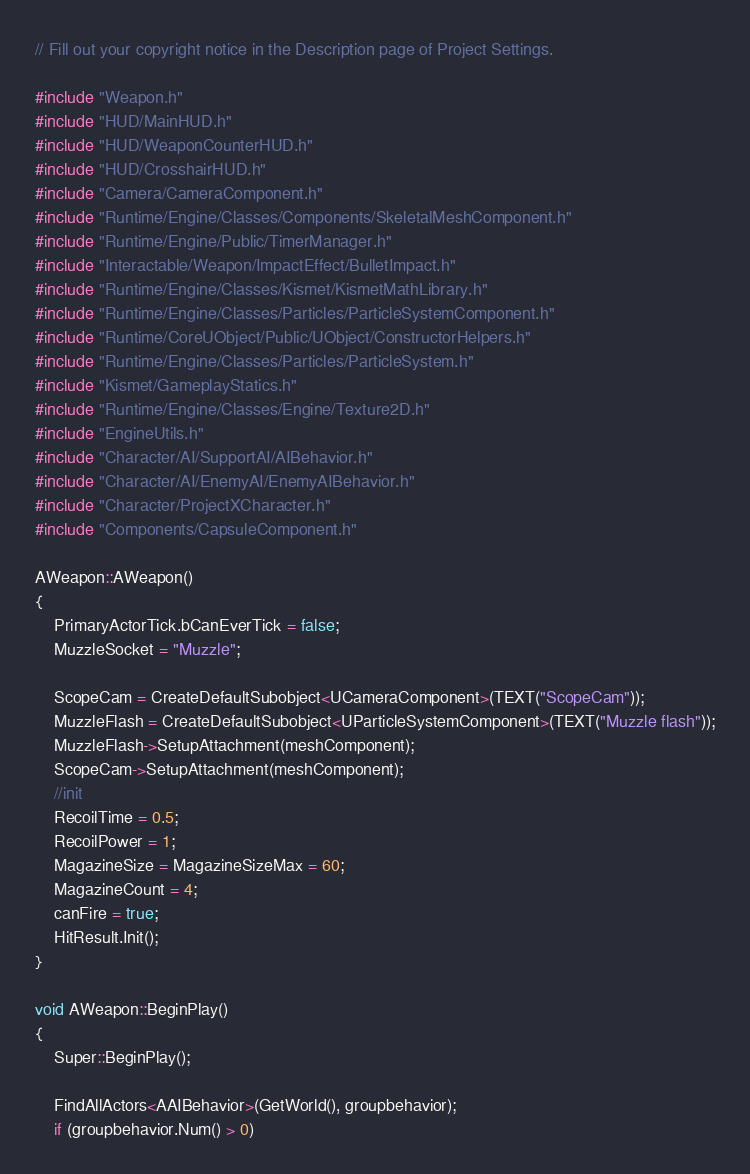Convert code to text. <code><loc_0><loc_0><loc_500><loc_500><_C++_>// Fill out your copyright notice in the Description page of Project Settings.

#include "Weapon.h"
#include "HUD/MainHUD.h"
#include "HUD/WeaponCounterHUD.h"
#include "HUD/CrosshairHUD.h"
#include "Camera/CameraComponent.h"
#include "Runtime/Engine/Classes/Components/SkeletalMeshComponent.h"
#include "Runtime/Engine/Public/TimerManager.h"
#include "Interactable/Weapon/ImpactEffect/BulletImpact.h"
#include "Runtime/Engine/Classes/Kismet/KismetMathLibrary.h"
#include "Runtime/Engine/Classes/Particles/ParticleSystemComponent.h"
#include "Runtime/CoreUObject/Public/UObject/ConstructorHelpers.h"
#include "Runtime/Engine/Classes/Particles/ParticleSystem.h"
#include "Kismet/GameplayStatics.h"
#include "Runtime/Engine/Classes/Engine/Texture2D.h"
#include "EngineUtils.h"
#include "Character/AI/SupportAI/AIBehavior.h"
#include "Character/AI/EnemyAI/EnemyAIBehavior.h"
#include "Character/ProjectXCharacter.h"
#include "Components/CapsuleComponent.h"

AWeapon::AWeapon()
{
	PrimaryActorTick.bCanEverTick = false;
	MuzzleSocket = "Muzzle";

	ScopeCam = CreateDefaultSubobject<UCameraComponent>(TEXT("ScopeCam"));
	MuzzleFlash = CreateDefaultSubobject<UParticleSystemComponent>(TEXT("Muzzle flash"));
	MuzzleFlash->SetupAttachment(meshComponent);
	ScopeCam->SetupAttachment(meshComponent);
	//init
	RecoilTime = 0.5;
	RecoilPower = 1;
	MagazineSize = MagazineSizeMax = 60;
	MagazineCount = 4;
	canFire = true;
	HitResult.Init();
}

void AWeapon::BeginPlay()
{
	Super::BeginPlay();

	FindAllActors<AAIBehavior>(GetWorld(), groupbehavior);
	if (groupbehavior.Num() > 0)</code> 